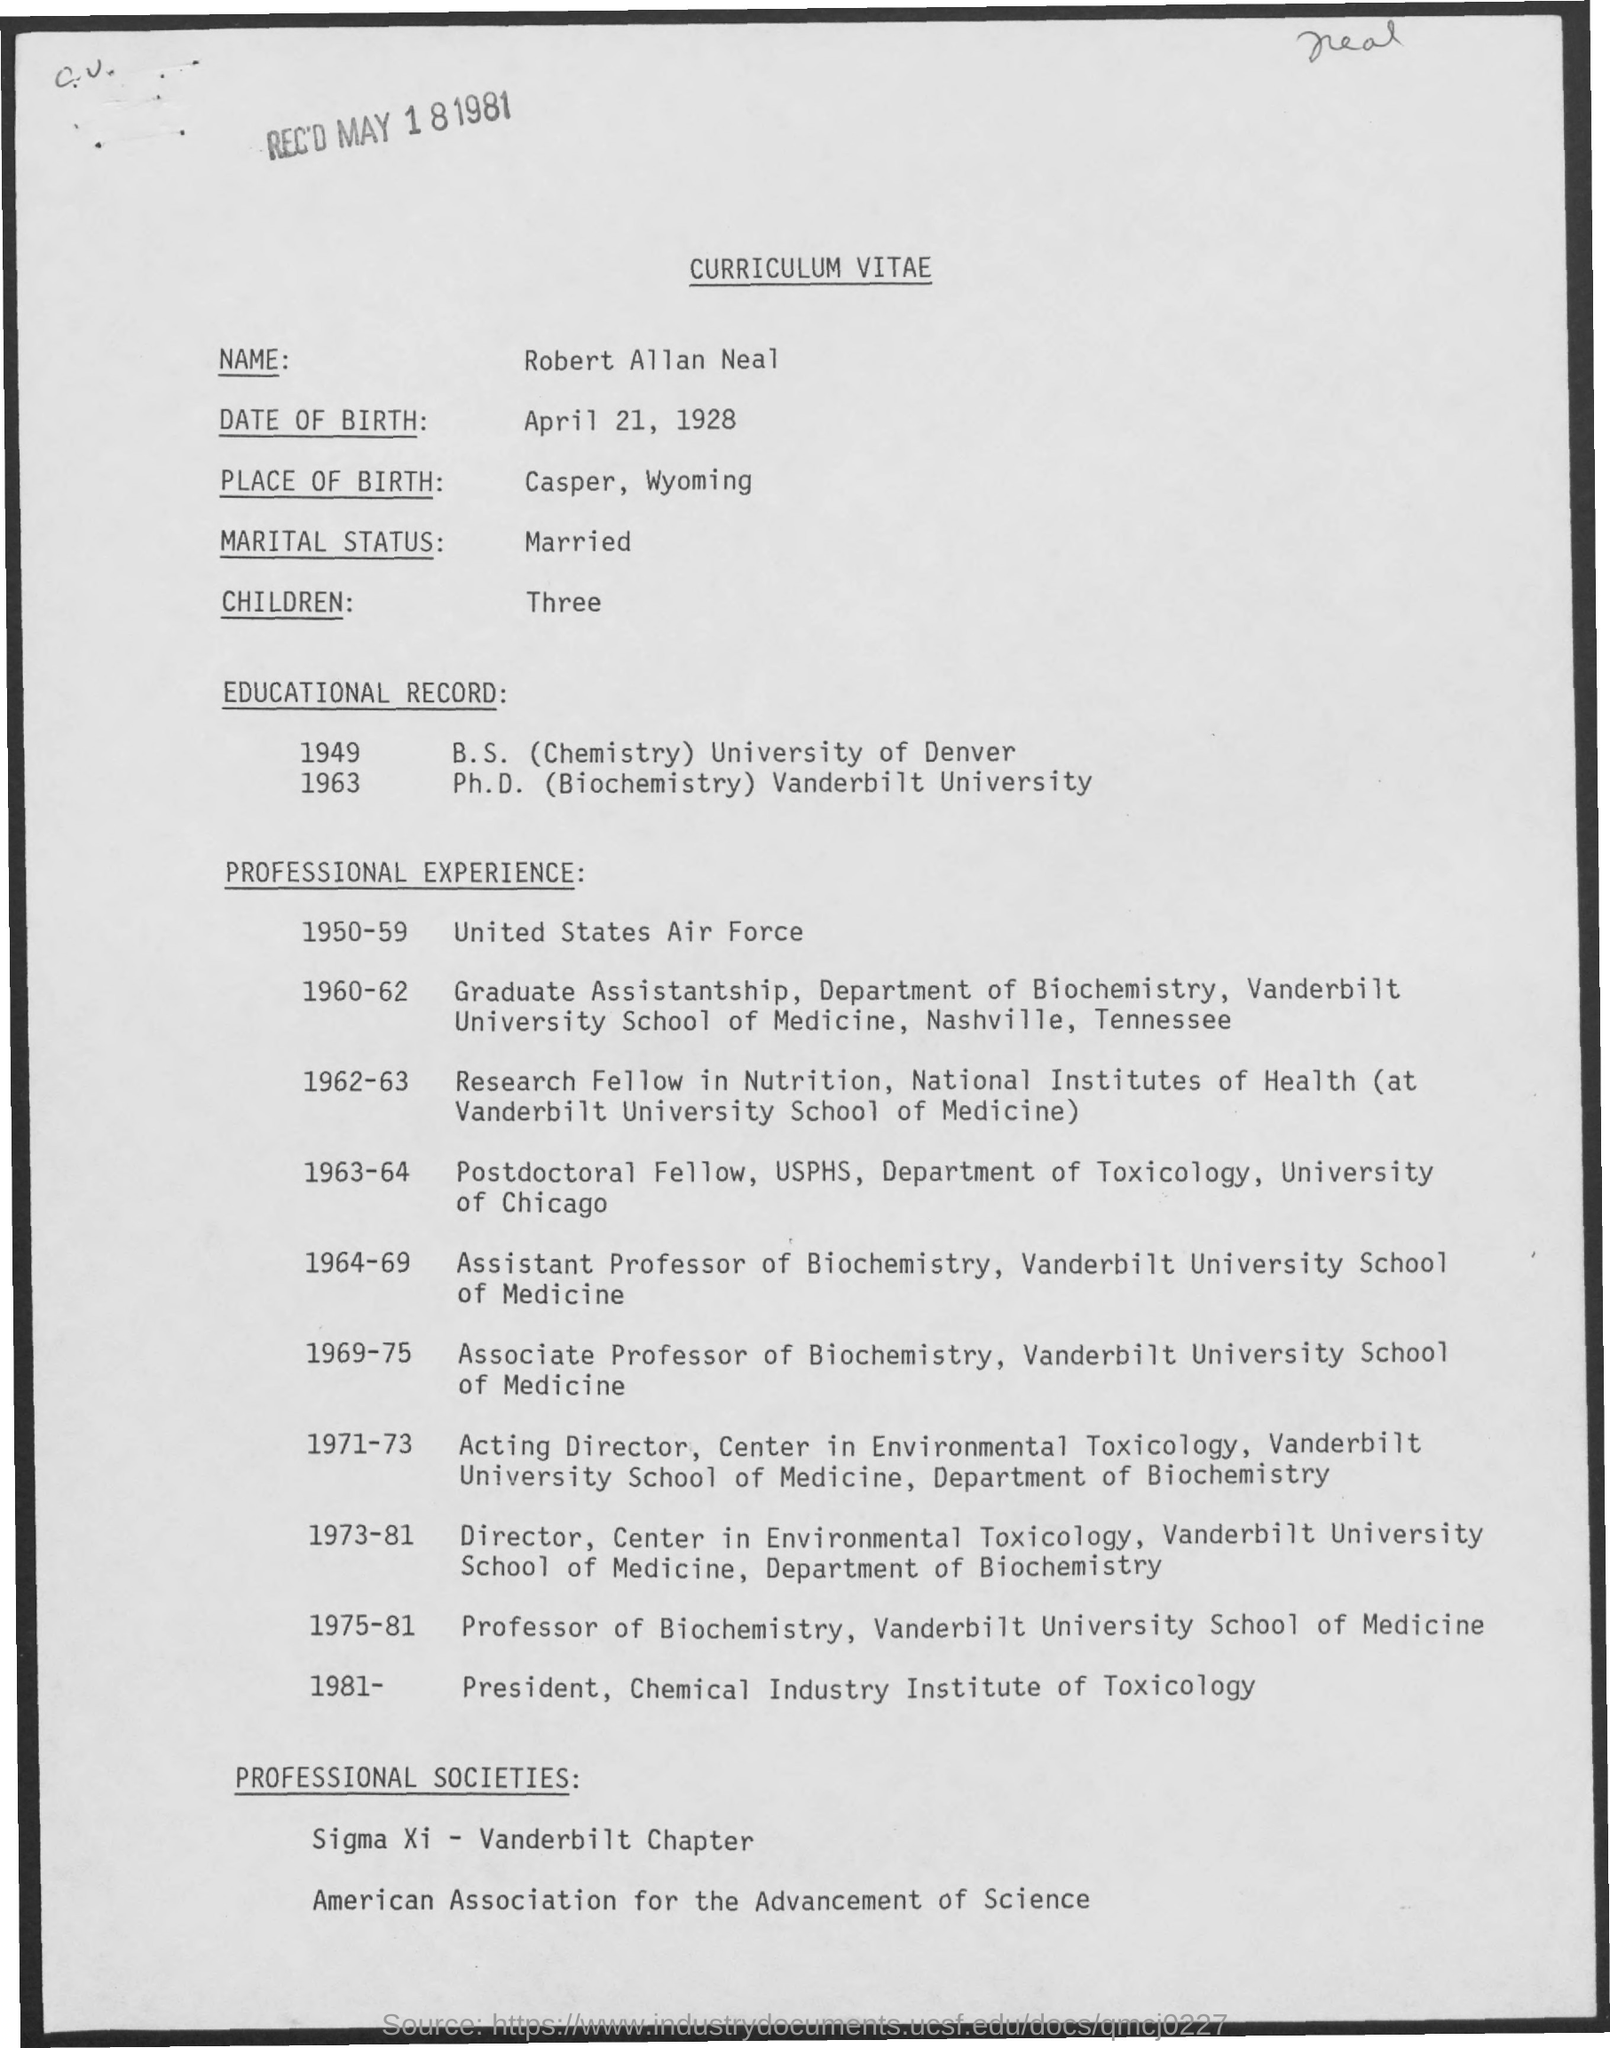Give some essential details in this illustration. The name is Robert Allan Neal. The title of the document is "Curriculum Vitae. I have three children. I, [Name], declare that my marital status is married. The place of birth is Casper, Wyoming. 